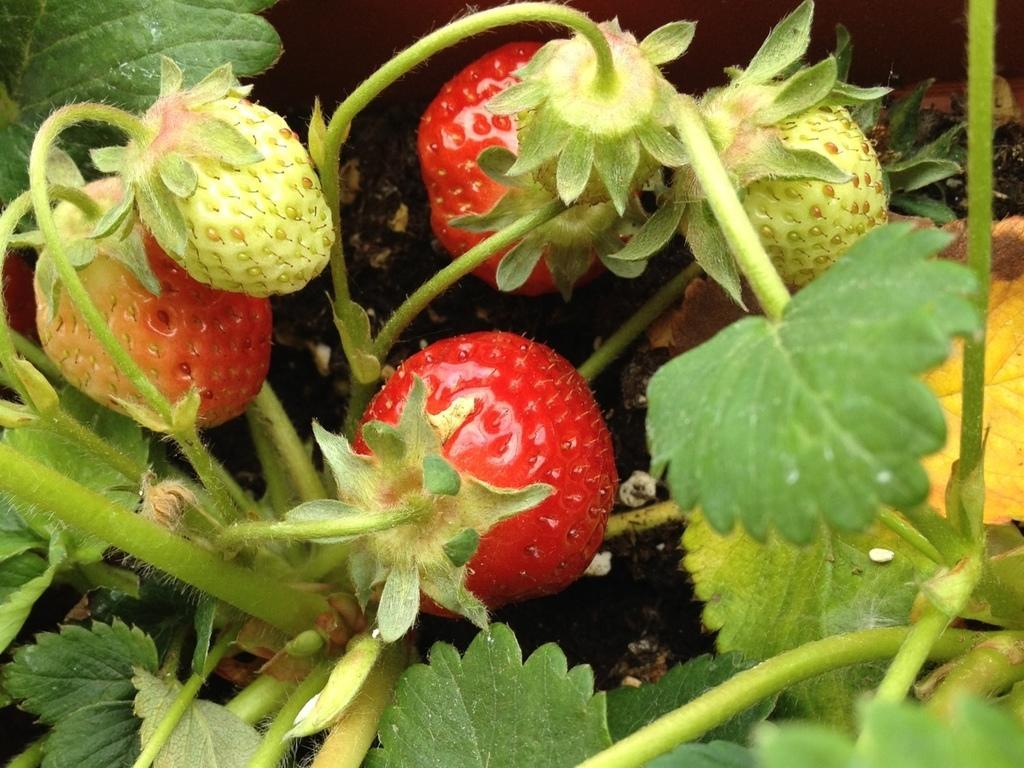Please provide a concise description of this image. In this picture we can see strawberries and leaves in the front, in the background there is soil. 